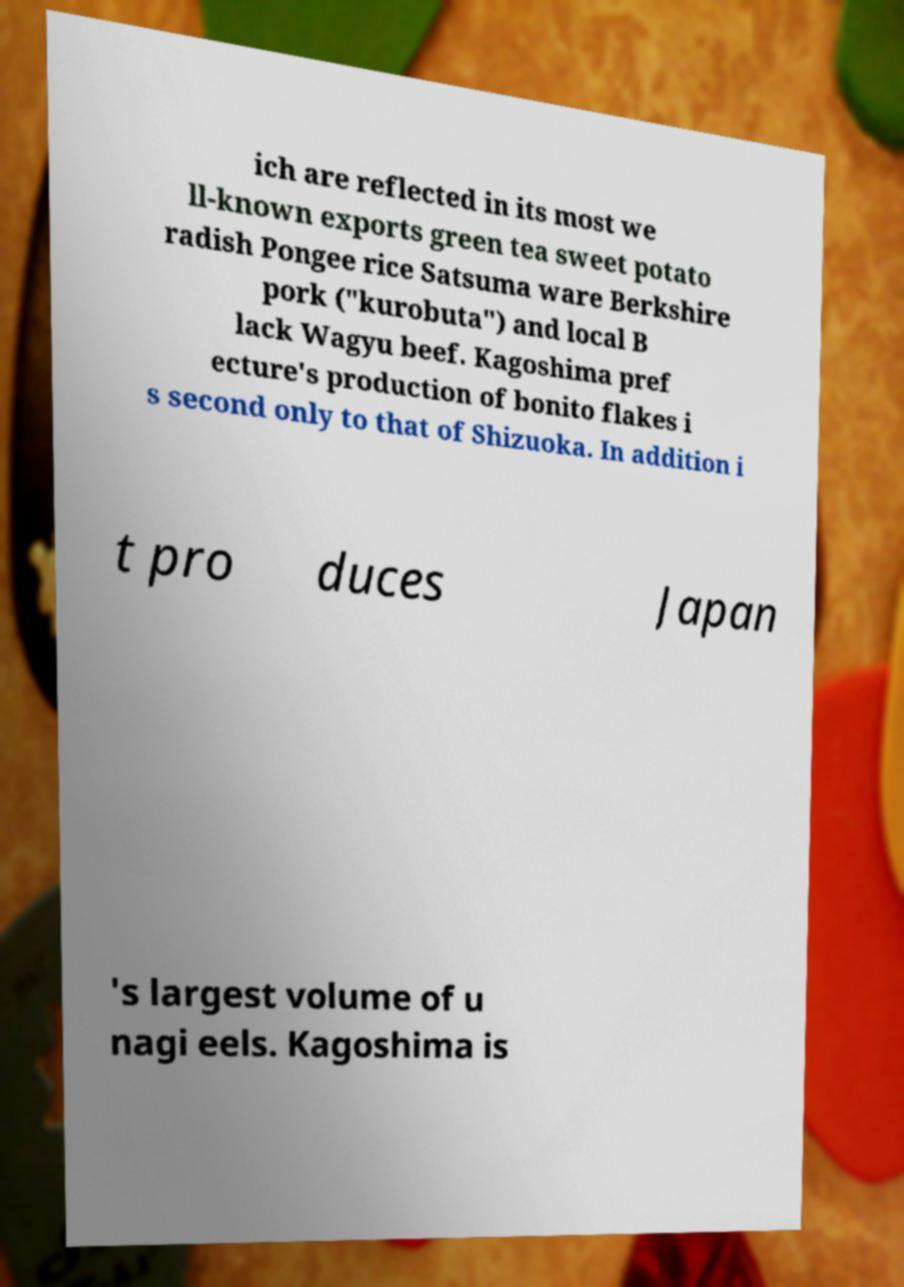Can you read and provide the text displayed in the image?This photo seems to have some interesting text. Can you extract and type it out for me? ich are reflected in its most we ll-known exports green tea sweet potato radish Pongee rice Satsuma ware Berkshire pork ("kurobuta") and local B lack Wagyu beef. Kagoshima pref ecture's production of bonito flakes i s second only to that of Shizuoka. In addition i t pro duces Japan 's largest volume of u nagi eels. Kagoshima is 